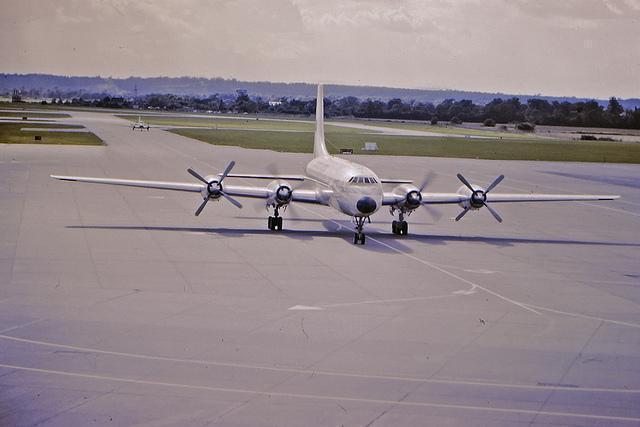Where is the vehicle located?
Select the accurate answer and provide justification: `Answer: choice
Rationale: srationale.`
Options: Runway, underground bunker, parking garage, sea. Answer: runway.
Rationale: A large concrete airstrip is found with several planes riding down it. 